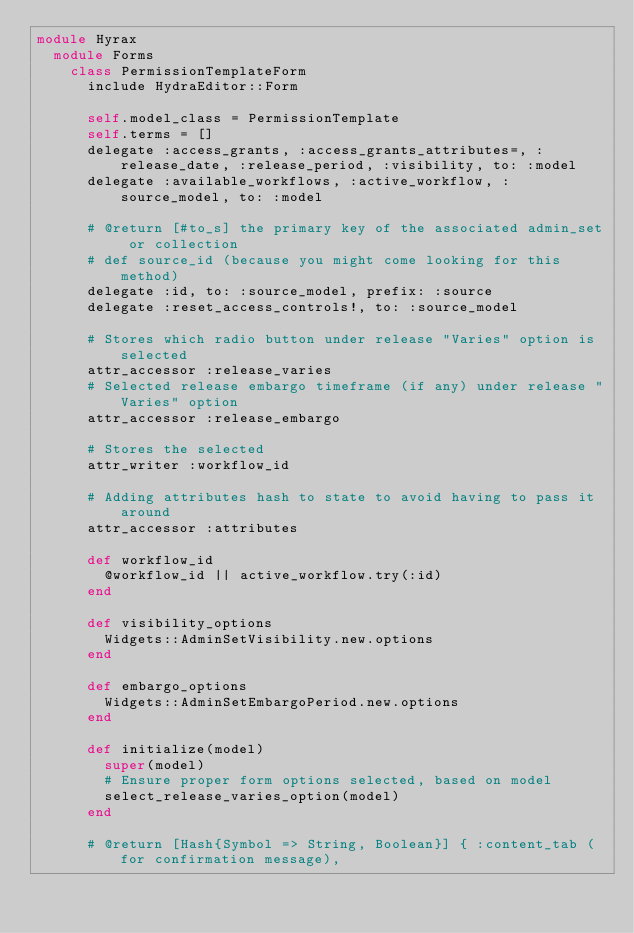<code> <loc_0><loc_0><loc_500><loc_500><_Ruby_>module Hyrax
  module Forms
    class PermissionTemplateForm
      include HydraEditor::Form

      self.model_class = PermissionTemplate
      self.terms = []
      delegate :access_grants, :access_grants_attributes=, :release_date, :release_period, :visibility, to: :model
      delegate :available_workflows, :active_workflow, :source_model, to: :model

      # @return [#to_s] the primary key of the associated admin_set or collection
      # def source_id (because you might come looking for this method)
      delegate :id, to: :source_model, prefix: :source
      delegate :reset_access_controls!, to: :source_model

      # Stores which radio button under release "Varies" option is selected
      attr_accessor :release_varies
      # Selected release embargo timeframe (if any) under release "Varies" option
      attr_accessor :release_embargo

      # Stores the selected
      attr_writer :workflow_id

      # Adding attributes hash to state to avoid having to pass it around
      attr_accessor :attributes

      def workflow_id
        @workflow_id || active_workflow.try(:id)
      end

      def visibility_options
        Widgets::AdminSetVisibility.new.options
      end

      def embargo_options
        Widgets::AdminSetEmbargoPeriod.new.options
      end

      def initialize(model)
        super(model)
        # Ensure proper form options selected, based on model
        select_release_varies_option(model)
      end

      # @return [Hash{Symbol => String, Boolean}] { :content_tab (for confirmation message),</code> 